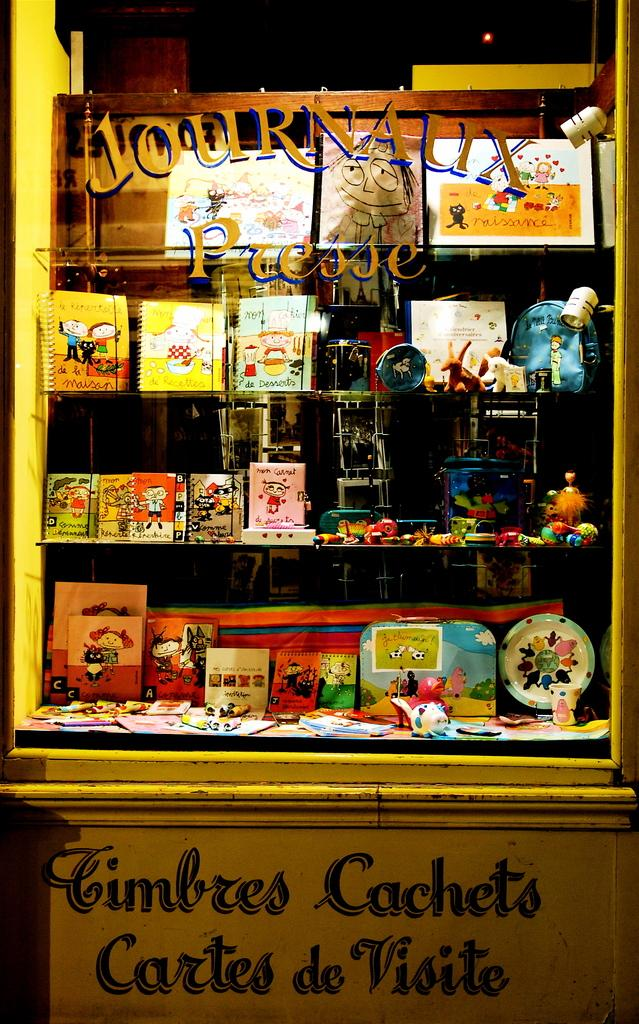What is the main object in the image? The image contains a glass box. What can be seen inside the glass box? There are items on the shelves inside the glass box. Is there any text visible in the image? Yes, there is text at the bottom of the picture and on the glass of the glass box. Can you describe the bird sitting on the chain inside the glass box? There is no bird or chain present inside the glass box in the image. What type of haircut does the person in the glass box have? There is no person visible inside the glass box in the image. 